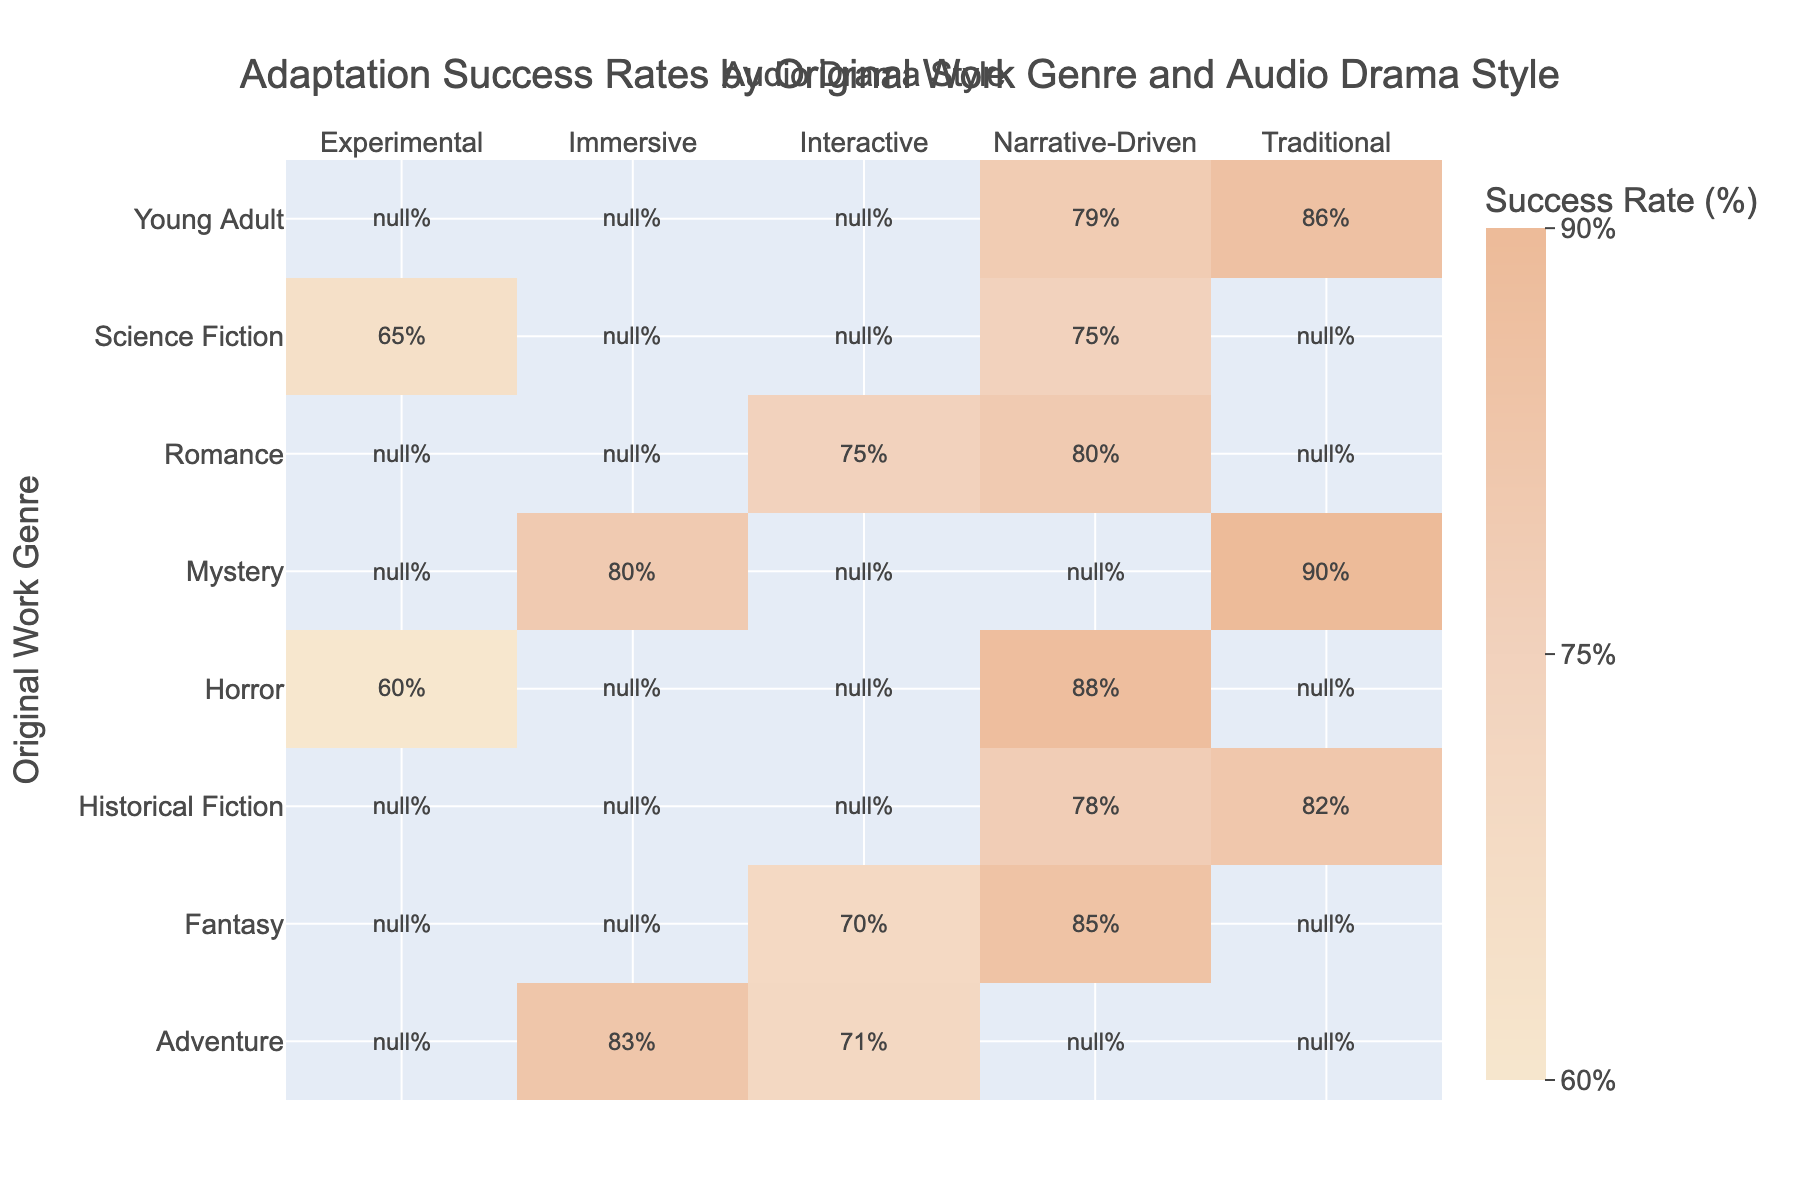What is the adaptation success rate percentage for Fantasy using a Narrative-Driven style? According to the table, the adaptation success rate percentage for Fantasy in the Narrative-Driven style is directly listed as 85%.
Answer: 85% What is the lowest adaptation success rate among the Horror adaptations? In the table, the Horror adaptations show two styles: Narrative-Driven at 88% and Experimental at 60%. The lowest of these two rates is 60%.
Answer: 60% Which Audio Drama Style has the highest adaptation success rate for Mystery? The table shows that Mystery adaptations have two success rates listed: Traditional at 90% and Immersive at 80%. The highest success rate here is 90% for the Traditional style.
Answer: 90% Is the success rate for Interactive adaptations in Romance higher than that in Young Adult? Looking at the data, the success rate for Interactive adaptations in Romance is 75%, while for Young Adult, it is not applicable since there are no Interactive adaptations listed. Therefore, we can't compare directly; it's only true for Romance.
Answer: No What is the average adaptation success rate for all Adventure adaptations? There are two Adventure adaptations listed: Immersive at 83% and Interactive at 71%. To find the average, we add these two rates: 83 + 71 = 154, and then divide by the number of styles, which is 2. So, 154/2 = 77%.
Answer: 77% Which genre has the highest success rate with Experimental audio drama style? The data reveals that only Science Fiction and Horror have adaptation rates for the Experimental style, showing 65% and 60%, respectively. Thus, Science Fiction holds the higher success rate at 65%.
Answer: 65% Is there any genre where the Narrative-Driven style has a success rate of 80% or more? Reviewing the table, we find that the genres Fantasy (85%), Mystery (90%), Horror (88%), and Young Adult (79%) have success rates above 80%, confirming that there are several genres meeting this criteria.
Answer: Yes What is the difference in adaptation success rates between Traditional and Narrative-Driven styles for Historical Fiction? For Historical Fiction adaptations, Traditional has a success rate of 82% while Narrative-Driven has a success rate of 78%. The difference is 82 - 78 = 4%, indicating Traditional style performs better.
Answer: 4% 